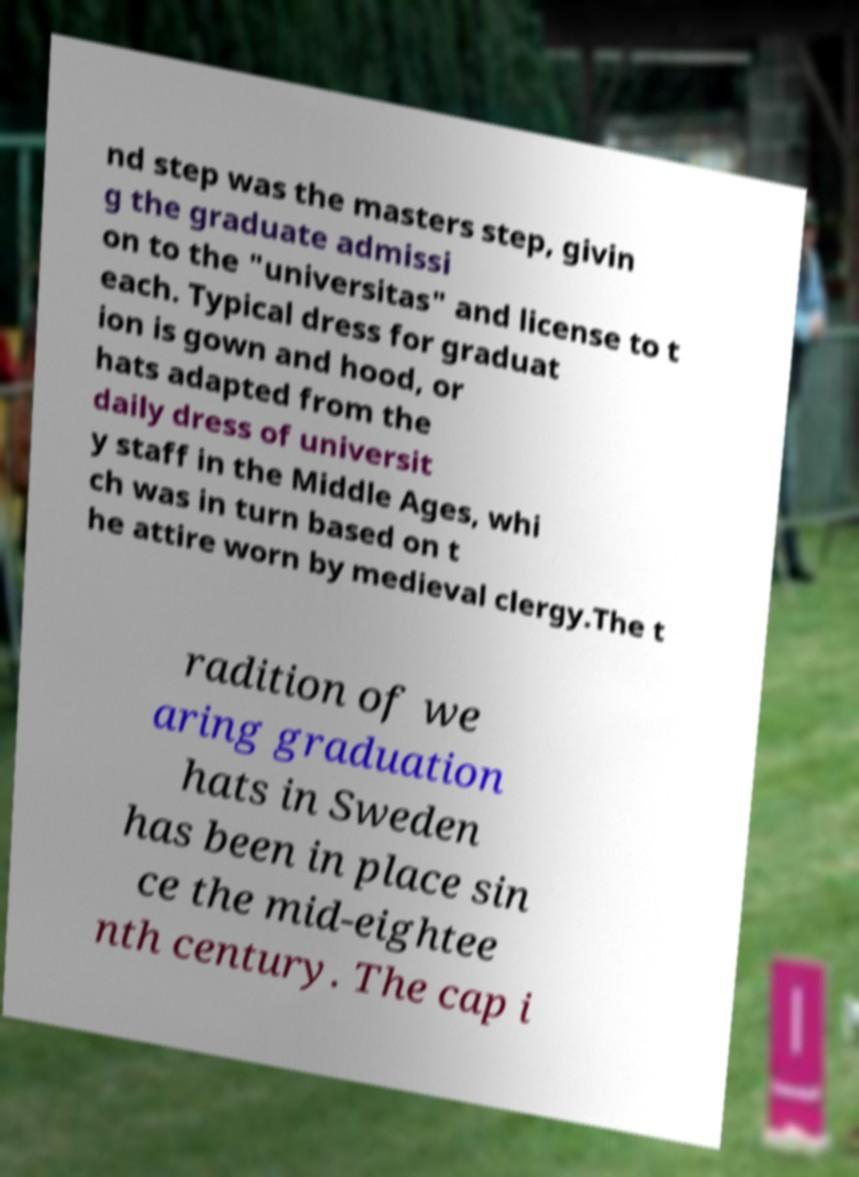Can you accurately transcribe the text from the provided image for me? nd step was the masters step, givin g the graduate admissi on to the "universitas" and license to t each. Typical dress for graduat ion is gown and hood, or hats adapted from the daily dress of universit y staff in the Middle Ages, whi ch was in turn based on t he attire worn by medieval clergy.The t radition of we aring graduation hats in Sweden has been in place sin ce the mid-eightee nth century. The cap i 